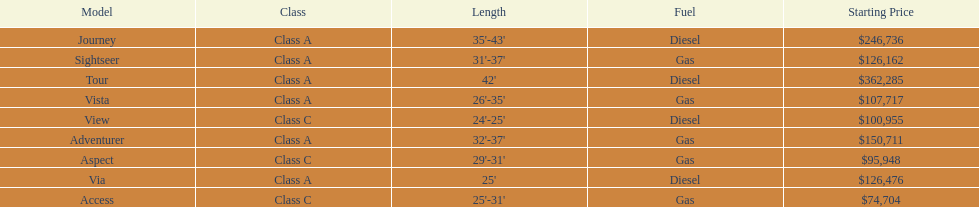Is the vista considered more important than the aspect? Yes. 